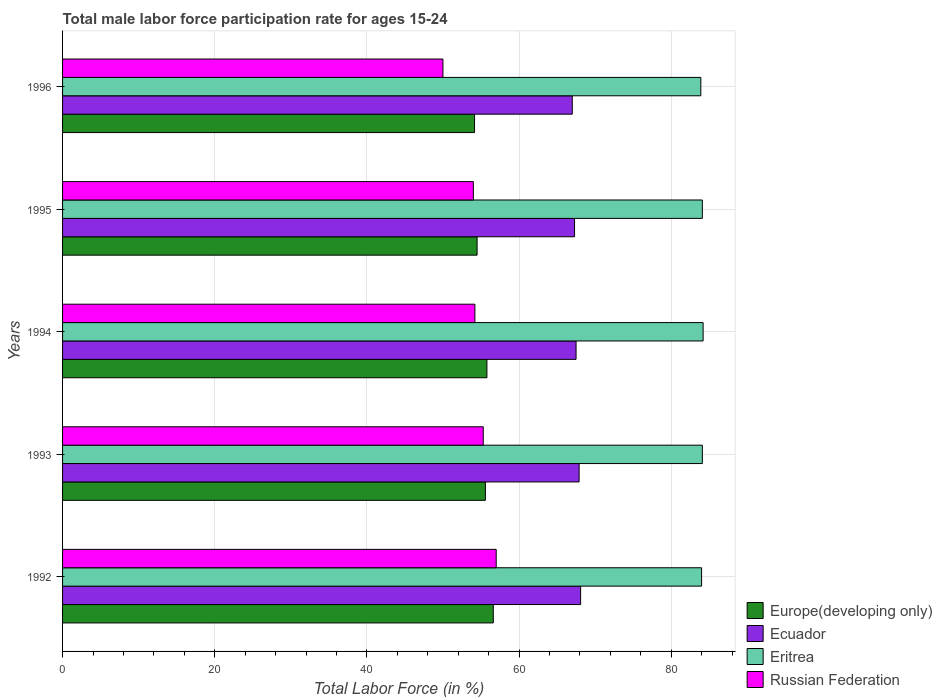How many groups of bars are there?
Provide a short and direct response. 5. Are the number of bars per tick equal to the number of legend labels?
Offer a very short reply. Yes. Are the number of bars on each tick of the Y-axis equal?
Provide a short and direct response. Yes. How many bars are there on the 1st tick from the bottom?
Provide a short and direct response. 4. What is the label of the 5th group of bars from the top?
Offer a terse response. 1992. Across all years, what is the maximum male labor force participation rate in Eritrea?
Your answer should be very brief. 84.2. Across all years, what is the minimum male labor force participation rate in Europe(developing only)?
Make the answer very short. 54.15. In which year was the male labor force participation rate in Europe(developing only) maximum?
Your response must be concise. 1992. What is the total male labor force participation rate in Ecuador in the graph?
Offer a terse response. 337.8. What is the difference between the male labor force participation rate in Eritrea in 1994 and that in 1995?
Your answer should be very brief. 0.1. What is the difference between the male labor force participation rate in Ecuador in 1994 and the male labor force participation rate in Europe(developing only) in 1995?
Ensure brevity in your answer.  13.01. What is the average male labor force participation rate in Eritrea per year?
Offer a very short reply. 84.06. In the year 1994, what is the difference between the male labor force participation rate in Ecuador and male labor force participation rate in Europe(developing only)?
Offer a very short reply. 11.72. In how many years, is the male labor force participation rate in Europe(developing only) greater than 84 %?
Ensure brevity in your answer.  0. What is the ratio of the male labor force participation rate in Eritrea in 1995 to that in 1996?
Keep it short and to the point. 1. Is the difference between the male labor force participation rate in Ecuador in 1993 and 1995 greater than the difference between the male labor force participation rate in Europe(developing only) in 1993 and 1995?
Provide a succinct answer. No. What is the difference between the highest and the second highest male labor force participation rate in Ecuador?
Provide a short and direct response. 0.2. What is the difference between the highest and the lowest male labor force participation rate in Ecuador?
Offer a very short reply. 1.1. In how many years, is the male labor force participation rate in Eritrea greater than the average male labor force participation rate in Eritrea taken over all years?
Ensure brevity in your answer.  3. Is the sum of the male labor force participation rate in Russian Federation in 1992 and 1995 greater than the maximum male labor force participation rate in Europe(developing only) across all years?
Provide a short and direct response. Yes. What does the 3rd bar from the top in 1995 represents?
Make the answer very short. Ecuador. What does the 1st bar from the bottom in 1992 represents?
Your response must be concise. Europe(developing only). Are all the bars in the graph horizontal?
Your answer should be compact. Yes. Does the graph contain grids?
Your answer should be very brief. Yes. Where does the legend appear in the graph?
Give a very brief answer. Bottom right. How many legend labels are there?
Ensure brevity in your answer.  4. What is the title of the graph?
Provide a short and direct response. Total male labor force participation rate for ages 15-24. Does "Armenia" appear as one of the legend labels in the graph?
Offer a very short reply. No. What is the label or title of the Y-axis?
Ensure brevity in your answer.  Years. What is the Total Labor Force (in %) in Europe(developing only) in 1992?
Give a very brief answer. 56.62. What is the Total Labor Force (in %) in Ecuador in 1992?
Your answer should be very brief. 68.1. What is the Total Labor Force (in %) of Europe(developing only) in 1993?
Your answer should be compact. 55.58. What is the Total Labor Force (in %) in Ecuador in 1993?
Ensure brevity in your answer.  67.9. What is the Total Labor Force (in %) of Eritrea in 1993?
Your answer should be very brief. 84.1. What is the Total Labor Force (in %) of Russian Federation in 1993?
Your answer should be compact. 55.3. What is the Total Labor Force (in %) in Europe(developing only) in 1994?
Offer a very short reply. 55.78. What is the Total Labor Force (in %) in Ecuador in 1994?
Your response must be concise. 67.5. What is the Total Labor Force (in %) of Eritrea in 1994?
Your answer should be very brief. 84.2. What is the Total Labor Force (in %) in Russian Federation in 1994?
Keep it short and to the point. 54.2. What is the Total Labor Force (in %) of Europe(developing only) in 1995?
Provide a short and direct response. 54.49. What is the Total Labor Force (in %) in Ecuador in 1995?
Offer a very short reply. 67.3. What is the Total Labor Force (in %) in Eritrea in 1995?
Give a very brief answer. 84.1. What is the Total Labor Force (in %) in Europe(developing only) in 1996?
Offer a very short reply. 54.15. What is the Total Labor Force (in %) of Ecuador in 1996?
Keep it short and to the point. 67. What is the Total Labor Force (in %) in Eritrea in 1996?
Ensure brevity in your answer.  83.9. Across all years, what is the maximum Total Labor Force (in %) in Europe(developing only)?
Keep it short and to the point. 56.62. Across all years, what is the maximum Total Labor Force (in %) in Ecuador?
Keep it short and to the point. 68.1. Across all years, what is the maximum Total Labor Force (in %) of Eritrea?
Your answer should be very brief. 84.2. Across all years, what is the minimum Total Labor Force (in %) in Europe(developing only)?
Offer a terse response. 54.15. Across all years, what is the minimum Total Labor Force (in %) in Ecuador?
Offer a terse response. 67. Across all years, what is the minimum Total Labor Force (in %) of Eritrea?
Ensure brevity in your answer.  83.9. What is the total Total Labor Force (in %) of Europe(developing only) in the graph?
Offer a very short reply. 276.63. What is the total Total Labor Force (in %) in Ecuador in the graph?
Your answer should be very brief. 337.8. What is the total Total Labor Force (in %) of Eritrea in the graph?
Ensure brevity in your answer.  420.3. What is the total Total Labor Force (in %) of Russian Federation in the graph?
Offer a terse response. 270.5. What is the difference between the Total Labor Force (in %) in Europe(developing only) in 1992 and that in 1993?
Ensure brevity in your answer.  1.04. What is the difference between the Total Labor Force (in %) of Eritrea in 1992 and that in 1993?
Offer a very short reply. -0.1. What is the difference between the Total Labor Force (in %) of Europe(developing only) in 1992 and that in 1994?
Provide a succinct answer. 0.84. What is the difference between the Total Labor Force (in %) of Eritrea in 1992 and that in 1994?
Make the answer very short. -0.2. What is the difference between the Total Labor Force (in %) of Europe(developing only) in 1992 and that in 1995?
Offer a terse response. 2.13. What is the difference between the Total Labor Force (in %) of Eritrea in 1992 and that in 1995?
Give a very brief answer. -0.1. What is the difference between the Total Labor Force (in %) in Europe(developing only) in 1992 and that in 1996?
Give a very brief answer. 2.46. What is the difference between the Total Labor Force (in %) of Eritrea in 1992 and that in 1996?
Provide a succinct answer. 0.1. What is the difference between the Total Labor Force (in %) of Russian Federation in 1992 and that in 1996?
Your response must be concise. 7. What is the difference between the Total Labor Force (in %) of Europe(developing only) in 1993 and that in 1994?
Keep it short and to the point. -0.2. What is the difference between the Total Labor Force (in %) in Eritrea in 1993 and that in 1994?
Provide a short and direct response. -0.1. What is the difference between the Total Labor Force (in %) of Europe(developing only) in 1993 and that in 1995?
Offer a terse response. 1.09. What is the difference between the Total Labor Force (in %) of Ecuador in 1993 and that in 1995?
Provide a succinct answer. 0.6. What is the difference between the Total Labor Force (in %) in Russian Federation in 1993 and that in 1995?
Provide a succinct answer. 1.3. What is the difference between the Total Labor Force (in %) of Europe(developing only) in 1993 and that in 1996?
Offer a very short reply. 1.43. What is the difference between the Total Labor Force (in %) in Ecuador in 1993 and that in 1996?
Your response must be concise. 0.9. What is the difference between the Total Labor Force (in %) in Europe(developing only) in 1994 and that in 1995?
Offer a very short reply. 1.29. What is the difference between the Total Labor Force (in %) of Ecuador in 1994 and that in 1995?
Ensure brevity in your answer.  0.2. What is the difference between the Total Labor Force (in %) in Europe(developing only) in 1994 and that in 1996?
Give a very brief answer. 1.63. What is the difference between the Total Labor Force (in %) of Europe(developing only) in 1995 and that in 1996?
Your answer should be very brief. 0.34. What is the difference between the Total Labor Force (in %) of Europe(developing only) in 1992 and the Total Labor Force (in %) of Ecuador in 1993?
Offer a terse response. -11.28. What is the difference between the Total Labor Force (in %) of Europe(developing only) in 1992 and the Total Labor Force (in %) of Eritrea in 1993?
Ensure brevity in your answer.  -27.48. What is the difference between the Total Labor Force (in %) in Europe(developing only) in 1992 and the Total Labor Force (in %) in Russian Federation in 1993?
Provide a succinct answer. 1.32. What is the difference between the Total Labor Force (in %) in Ecuador in 1992 and the Total Labor Force (in %) in Eritrea in 1993?
Your response must be concise. -16. What is the difference between the Total Labor Force (in %) of Eritrea in 1992 and the Total Labor Force (in %) of Russian Federation in 1993?
Ensure brevity in your answer.  28.7. What is the difference between the Total Labor Force (in %) of Europe(developing only) in 1992 and the Total Labor Force (in %) of Ecuador in 1994?
Keep it short and to the point. -10.88. What is the difference between the Total Labor Force (in %) of Europe(developing only) in 1992 and the Total Labor Force (in %) of Eritrea in 1994?
Offer a terse response. -27.58. What is the difference between the Total Labor Force (in %) in Europe(developing only) in 1992 and the Total Labor Force (in %) in Russian Federation in 1994?
Keep it short and to the point. 2.42. What is the difference between the Total Labor Force (in %) in Ecuador in 1992 and the Total Labor Force (in %) in Eritrea in 1994?
Ensure brevity in your answer.  -16.1. What is the difference between the Total Labor Force (in %) of Ecuador in 1992 and the Total Labor Force (in %) of Russian Federation in 1994?
Keep it short and to the point. 13.9. What is the difference between the Total Labor Force (in %) of Eritrea in 1992 and the Total Labor Force (in %) of Russian Federation in 1994?
Offer a very short reply. 29.8. What is the difference between the Total Labor Force (in %) of Europe(developing only) in 1992 and the Total Labor Force (in %) of Ecuador in 1995?
Offer a very short reply. -10.68. What is the difference between the Total Labor Force (in %) of Europe(developing only) in 1992 and the Total Labor Force (in %) of Eritrea in 1995?
Ensure brevity in your answer.  -27.48. What is the difference between the Total Labor Force (in %) in Europe(developing only) in 1992 and the Total Labor Force (in %) in Russian Federation in 1995?
Your response must be concise. 2.62. What is the difference between the Total Labor Force (in %) of Europe(developing only) in 1992 and the Total Labor Force (in %) of Ecuador in 1996?
Your answer should be compact. -10.38. What is the difference between the Total Labor Force (in %) in Europe(developing only) in 1992 and the Total Labor Force (in %) in Eritrea in 1996?
Offer a terse response. -27.28. What is the difference between the Total Labor Force (in %) of Europe(developing only) in 1992 and the Total Labor Force (in %) of Russian Federation in 1996?
Give a very brief answer. 6.62. What is the difference between the Total Labor Force (in %) in Ecuador in 1992 and the Total Labor Force (in %) in Eritrea in 1996?
Give a very brief answer. -15.8. What is the difference between the Total Labor Force (in %) of Eritrea in 1992 and the Total Labor Force (in %) of Russian Federation in 1996?
Offer a very short reply. 34. What is the difference between the Total Labor Force (in %) of Europe(developing only) in 1993 and the Total Labor Force (in %) of Ecuador in 1994?
Give a very brief answer. -11.92. What is the difference between the Total Labor Force (in %) of Europe(developing only) in 1993 and the Total Labor Force (in %) of Eritrea in 1994?
Your response must be concise. -28.62. What is the difference between the Total Labor Force (in %) in Europe(developing only) in 1993 and the Total Labor Force (in %) in Russian Federation in 1994?
Ensure brevity in your answer.  1.38. What is the difference between the Total Labor Force (in %) of Ecuador in 1993 and the Total Labor Force (in %) of Eritrea in 1994?
Ensure brevity in your answer.  -16.3. What is the difference between the Total Labor Force (in %) of Eritrea in 1993 and the Total Labor Force (in %) of Russian Federation in 1994?
Keep it short and to the point. 29.9. What is the difference between the Total Labor Force (in %) of Europe(developing only) in 1993 and the Total Labor Force (in %) of Ecuador in 1995?
Provide a succinct answer. -11.72. What is the difference between the Total Labor Force (in %) of Europe(developing only) in 1993 and the Total Labor Force (in %) of Eritrea in 1995?
Keep it short and to the point. -28.52. What is the difference between the Total Labor Force (in %) in Europe(developing only) in 1993 and the Total Labor Force (in %) in Russian Federation in 1995?
Your answer should be compact. 1.58. What is the difference between the Total Labor Force (in %) in Ecuador in 1993 and the Total Labor Force (in %) in Eritrea in 1995?
Your response must be concise. -16.2. What is the difference between the Total Labor Force (in %) of Ecuador in 1993 and the Total Labor Force (in %) of Russian Federation in 1995?
Offer a terse response. 13.9. What is the difference between the Total Labor Force (in %) in Eritrea in 1993 and the Total Labor Force (in %) in Russian Federation in 1995?
Provide a succinct answer. 30.1. What is the difference between the Total Labor Force (in %) in Europe(developing only) in 1993 and the Total Labor Force (in %) in Ecuador in 1996?
Ensure brevity in your answer.  -11.42. What is the difference between the Total Labor Force (in %) of Europe(developing only) in 1993 and the Total Labor Force (in %) of Eritrea in 1996?
Your response must be concise. -28.32. What is the difference between the Total Labor Force (in %) in Europe(developing only) in 1993 and the Total Labor Force (in %) in Russian Federation in 1996?
Offer a very short reply. 5.58. What is the difference between the Total Labor Force (in %) of Ecuador in 1993 and the Total Labor Force (in %) of Russian Federation in 1996?
Provide a short and direct response. 17.9. What is the difference between the Total Labor Force (in %) of Eritrea in 1993 and the Total Labor Force (in %) of Russian Federation in 1996?
Provide a succinct answer. 34.1. What is the difference between the Total Labor Force (in %) in Europe(developing only) in 1994 and the Total Labor Force (in %) in Ecuador in 1995?
Your answer should be very brief. -11.52. What is the difference between the Total Labor Force (in %) of Europe(developing only) in 1994 and the Total Labor Force (in %) of Eritrea in 1995?
Your answer should be very brief. -28.32. What is the difference between the Total Labor Force (in %) of Europe(developing only) in 1994 and the Total Labor Force (in %) of Russian Federation in 1995?
Your answer should be very brief. 1.78. What is the difference between the Total Labor Force (in %) in Ecuador in 1994 and the Total Labor Force (in %) in Eritrea in 1995?
Your answer should be very brief. -16.6. What is the difference between the Total Labor Force (in %) in Ecuador in 1994 and the Total Labor Force (in %) in Russian Federation in 1995?
Provide a succinct answer. 13.5. What is the difference between the Total Labor Force (in %) of Eritrea in 1994 and the Total Labor Force (in %) of Russian Federation in 1995?
Your answer should be compact. 30.2. What is the difference between the Total Labor Force (in %) of Europe(developing only) in 1994 and the Total Labor Force (in %) of Ecuador in 1996?
Offer a terse response. -11.22. What is the difference between the Total Labor Force (in %) of Europe(developing only) in 1994 and the Total Labor Force (in %) of Eritrea in 1996?
Keep it short and to the point. -28.12. What is the difference between the Total Labor Force (in %) in Europe(developing only) in 1994 and the Total Labor Force (in %) in Russian Federation in 1996?
Your answer should be compact. 5.78. What is the difference between the Total Labor Force (in %) in Ecuador in 1994 and the Total Labor Force (in %) in Eritrea in 1996?
Keep it short and to the point. -16.4. What is the difference between the Total Labor Force (in %) of Ecuador in 1994 and the Total Labor Force (in %) of Russian Federation in 1996?
Provide a short and direct response. 17.5. What is the difference between the Total Labor Force (in %) of Eritrea in 1994 and the Total Labor Force (in %) of Russian Federation in 1996?
Your answer should be very brief. 34.2. What is the difference between the Total Labor Force (in %) of Europe(developing only) in 1995 and the Total Labor Force (in %) of Ecuador in 1996?
Provide a succinct answer. -12.51. What is the difference between the Total Labor Force (in %) of Europe(developing only) in 1995 and the Total Labor Force (in %) of Eritrea in 1996?
Your response must be concise. -29.41. What is the difference between the Total Labor Force (in %) in Europe(developing only) in 1995 and the Total Labor Force (in %) in Russian Federation in 1996?
Your response must be concise. 4.49. What is the difference between the Total Labor Force (in %) in Ecuador in 1995 and the Total Labor Force (in %) in Eritrea in 1996?
Make the answer very short. -16.6. What is the difference between the Total Labor Force (in %) in Ecuador in 1995 and the Total Labor Force (in %) in Russian Federation in 1996?
Your answer should be very brief. 17.3. What is the difference between the Total Labor Force (in %) in Eritrea in 1995 and the Total Labor Force (in %) in Russian Federation in 1996?
Ensure brevity in your answer.  34.1. What is the average Total Labor Force (in %) of Europe(developing only) per year?
Keep it short and to the point. 55.33. What is the average Total Labor Force (in %) of Ecuador per year?
Offer a very short reply. 67.56. What is the average Total Labor Force (in %) in Eritrea per year?
Ensure brevity in your answer.  84.06. What is the average Total Labor Force (in %) of Russian Federation per year?
Your answer should be very brief. 54.1. In the year 1992, what is the difference between the Total Labor Force (in %) in Europe(developing only) and Total Labor Force (in %) in Ecuador?
Your answer should be very brief. -11.48. In the year 1992, what is the difference between the Total Labor Force (in %) in Europe(developing only) and Total Labor Force (in %) in Eritrea?
Give a very brief answer. -27.38. In the year 1992, what is the difference between the Total Labor Force (in %) in Europe(developing only) and Total Labor Force (in %) in Russian Federation?
Ensure brevity in your answer.  -0.38. In the year 1992, what is the difference between the Total Labor Force (in %) in Ecuador and Total Labor Force (in %) in Eritrea?
Provide a succinct answer. -15.9. In the year 1992, what is the difference between the Total Labor Force (in %) of Ecuador and Total Labor Force (in %) of Russian Federation?
Offer a terse response. 11.1. In the year 1992, what is the difference between the Total Labor Force (in %) of Eritrea and Total Labor Force (in %) of Russian Federation?
Your answer should be compact. 27. In the year 1993, what is the difference between the Total Labor Force (in %) of Europe(developing only) and Total Labor Force (in %) of Ecuador?
Ensure brevity in your answer.  -12.32. In the year 1993, what is the difference between the Total Labor Force (in %) in Europe(developing only) and Total Labor Force (in %) in Eritrea?
Your answer should be compact. -28.52. In the year 1993, what is the difference between the Total Labor Force (in %) in Europe(developing only) and Total Labor Force (in %) in Russian Federation?
Offer a terse response. 0.28. In the year 1993, what is the difference between the Total Labor Force (in %) of Ecuador and Total Labor Force (in %) of Eritrea?
Give a very brief answer. -16.2. In the year 1993, what is the difference between the Total Labor Force (in %) of Ecuador and Total Labor Force (in %) of Russian Federation?
Keep it short and to the point. 12.6. In the year 1993, what is the difference between the Total Labor Force (in %) in Eritrea and Total Labor Force (in %) in Russian Federation?
Keep it short and to the point. 28.8. In the year 1994, what is the difference between the Total Labor Force (in %) in Europe(developing only) and Total Labor Force (in %) in Ecuador?
Ensure brevity in your answer.  -11.72. In the year 1994, what is the difference between the Total Labor Force (in %) of Europe(developing only) and Total Labor Force (in %) of Eritrea?
Make the answer very short. -28.42. In the year 1994, what is the difference between the Total Labor Force (in %) of Europe(developing only) and Total Labor Force (in %) of Russian Federation?
Provide a succinct answer. 1.58. In the year 1994, what is the difference between the Total Labor Force (in %) in Ecuador and Total Labor Force (in %) in Eritrea?
Make the answer very short. -16.7. In the year 1994, what is the difference between the Total Labor Force (in %) in Eritrea and Total Labor Force (in %) in Russian Federation?
Your answer should be compact. 30. In the year 1995, what is the difference between the Total Labor Force (in %) in Europe(developing only) and Total Labor Force (in %) in Ecuador?
Ensure brevity in your answer.  -12.81. In the year 1995, what is the difference between the Total Labor Force (in %) in Europe(developing only) and Total Labor Force (in %) in Eritrea?
Offer a very short reply. -29.61. In the year 1995, what is the difference between the Total Labor Force (in %) in Europe(developing only) and Total Labor Force (in %) in Russian Federation?
Keep it short and to the point. 0.49. In the year 1995, what is the difference between the Total Labor Force (in %) of Ecuador and Total Labor Force (in %) of Eritrea?
Offer a very short reply. -16.8. In the year 1995, what is the difference between the Total Labor Force (in %) in Eritrea and Total Labor Force (in %) in Russian Federation?
Offer a terse response. 30.1. In the year 1996, what is the difference between the Total Labor Force (in %) of Europe(developing only) and Total Labor Force (in %) of Ecuador?
Keep it short and to the point. -12.85. In the year 1996, what is the difference between the Total Labor Force (in %) of Europe(developing only) and Total Labor Force (in %) of Eritrea?
Your answer should be compact. -29.75. In the year 1996, what is the difference between the Total Labor Force (in %) of Europe(developing only) and Total Labor Force (in %) of Russian Federation?
Offer a terse response. 4.15. In the year 1996, what is the difference between the Total Labor Force (in %) in Ecuador and Total Labor Force (in %) in Eritrea?
Offer a very short reply. -16.9. In the year 1996, what is the difference between the Total Labor Force (in %) in Ecuador and Total Labor Force (in %) in Russian Federation?
Your answer should be compact. 17. In the year 1996, what is the difference between the Total Labor Force (in %) of Eritrea and Total Labor Force (in %) of Russian Federation?
Give a very brief answer. 33.9. What is the ratio of the Total Labor Force (in %) in Europe(developing only) in 1992 to that in 1993?
Offer a very short reply. 1.02. What is the ratio of the Total Labor Force (in %) of Ecuador in 1992 to that in 1993?
Provide a short and direct response. 1. What is the ratio of the Total Labor Force (in %) of Eritrea in 1992 to that in 1993?
Your answer should be compact. 1. What is the ratio of the Total Labor Force (in %) in Russian Federation in 1992 to that in 1993?
Provide a short and direct response. 1.03. What is the ratio of the Total Labor Force (in %) in Europe(developing only) in 1992 to that in 1994?
Ensure brevity in your answer.  1.01. What is the ratio of the Total Labor Force (in %) in Ecuador in 1992 to that in 1994?
Ensure brevity in your answer.  1.01. What is the ratio of the Total Labor Force (in %) in Russian Federation in 1992 to that in 1994?
Give a very brief answer. 1.05. What is the ratio of the Total Labor Force (in %) in Europe(developing only) in 1992 to that in 1995?
Provide a short and direct response. 1.04. What is the ratio of the Total Labor Force (in %) of Ecuador in 1992 to that in 1995?
Your response must be concise. 1.01. What is the ratio of the Total Labor Force (in %) in Russian Federation in 1992 to that in 1995?
Your response must be concise. 1.06. What is the ratio of the Total Labor Force (in %) in Europe(developing only) in 1992 to that in 1996?
Provide a short and direct response. 1.05. What is the ratio of the Total Labor Force (in %) of Ecuador in 1992 to that in 1996?
Make the answer very short. 1.02. What is the ratio of the Total Labor Force (in %) in Eritrea in 1992 to that in 1996?
Give a very brief answer. 1. What is the ratio of the Total Labor Force (in %) in Russian Federation in 1992 to that in 1996?
Offer a very short reply. 1.14. What is the ratio of the Total Labor Force (in %) of Ecuador in 1993 to that in 1994?
Keep it short and to the point. 1.01. What is the ratio of the Total Labor Force (in %) in Russian Federation in 1993 to that in 1994?
Your response must be concise. 1.02. What is the ratio of the Total Labor Force (in %) in Ecuador in 1993 to that in 1995?
Make the answer very short. 1.01. What is the ratio of the Total Labor Force (in %) of Eritrea in 1993 to that in 1995?
Provide a succinct answer. 1. What is the ratio of the Total Labor Force (in %) in Russian Federation in 1993 to that in 1995?
Your response must be concise. 1.02. What is the ratio of the Total Labor Force (in %) of Europe(developing only) in 1993 to that in 1996?
Ensure brevity in your answer.  1.03. What is the ratio of the Total Labor Force (in %) in Ecuador in 1993 to that in 1996?
Ensure brevity in your answer.  1.01. What is the ratio of the Total Labor Force (in %) of Russian Federation in 1993 to that in 1996?
Offer a very short reply. 1.11. What is the ratio of the Total Labor Force (in %) of Europe(developing only) in 1994 to that in 1995?
Your response must be concise. 1.02. What is the ratio of the Total Labor Force (in %) in Ecuador in 1994 to that in 1995?
Give a very brief answer. 1. What is the ratio of the Total Labor Force (in %) of Russian Federation in 1994 to that in 1995?
Provide a short and direct response. 1. What is the ratio of the Total Labor Force (in %) in Europe(developing only) in 1994 to that in 1996?
Your answer should be very brief. 1.03. What is the ratio of the Total Labor Force (in %) in Ecuador in 1994 to that in 1996?
Give a very brief answer. 1.01. What is the ratio of the Total Labor Force (in %) of Eritrea in 1994 to that in 1996?
Ensure brevity in your answer.  1. What is the ratio of the Total Labor Force (in %) in Russian Federation in 1994 to that in 1996?
Your response must be concise. 1.08. What is the ratio of the Total Labor Force (in %) of Europe(developing only) in 1995 to that in 1996?
Make the answer very short. 1.01. What is the ratio of the Total Labor Force (in %) of Ecuador in 1995 to that in 1996?
Your response must be concise. 1. What is the difference between the highest and the second highest Total Labor Force (in %) of Europe(developing only)?
Provide a succinct answer. 0.84. What is the difference between the highest and the second highest Total Labor Force (in %) of Eritrea?
Your answer should be compact. 0.1. What is the difference between the highest and the second highest Total Labor Force (in %) in Russian Federation?
Your response must be concise. 1.7. What is the difference between the highest and the lowest Total Labor Force (in %) of Europe(developing only)?
Your answer should be very brief. 2.46. What is the difference between the highest and the lowest Total Labor Force (in %) of Ecuador?
Keep it short and to the point. 1.1. What is the difference between the highest and the lowest Total Labor Force (in %) of Eritrea?
Provide a short and direct response. 0.3. 